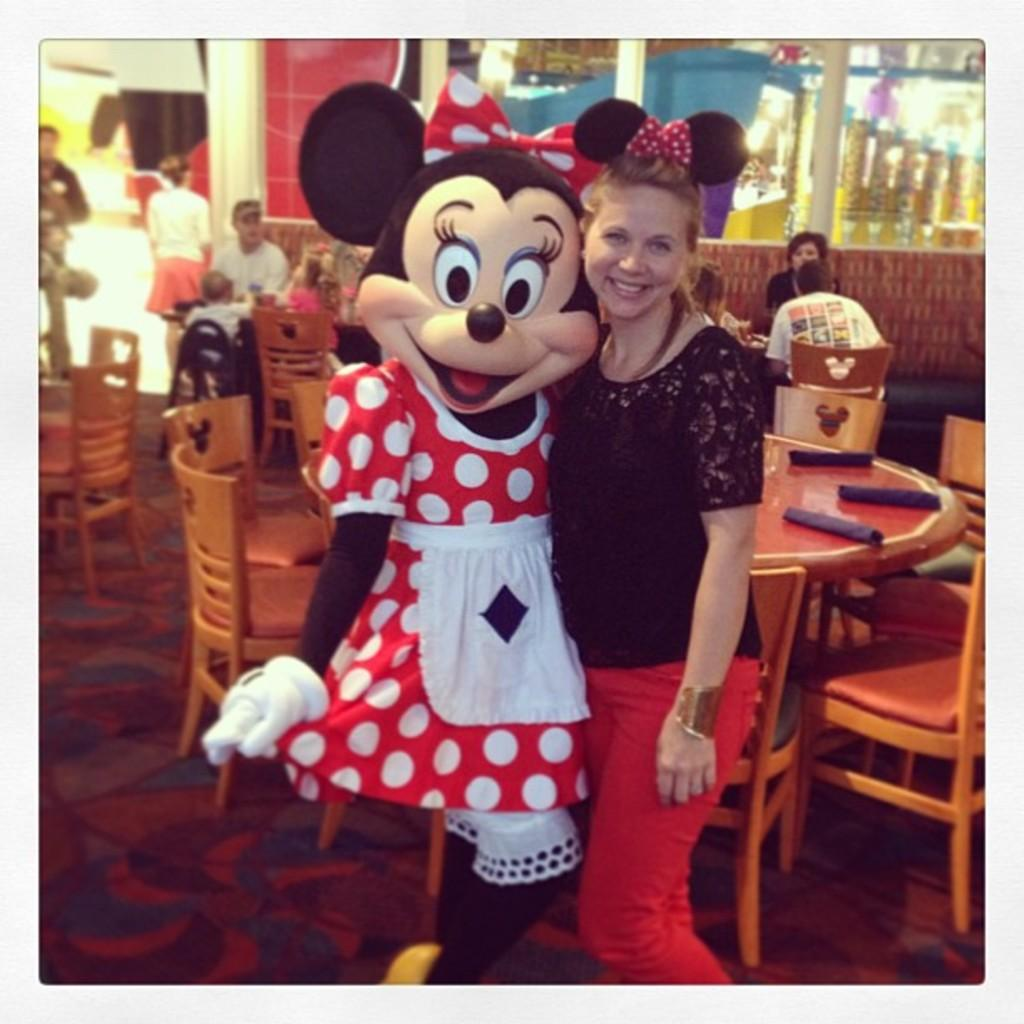Who is present in the image? There is a woman and Mickey Mouse in the image. What are the expressions of the woman and Mickey Mouse? Both the woman and Mickey Mouse are smiling. What can be seen in the background of the image? There are chairs, tables, and people. What type of coal is being used to fuel the pot in the image? There is no coal or pot present in the image. What is the purpose of the meeting taking place in the image? There is no meeting or indication of a meeting taking place in the image. 